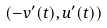Convert formula to latex. <formula><loc_0><loc_0><loc_500><loc_500>( - v ^ { \prime } ( t ) , u ^ { \prime } ( t ) )</formula> 